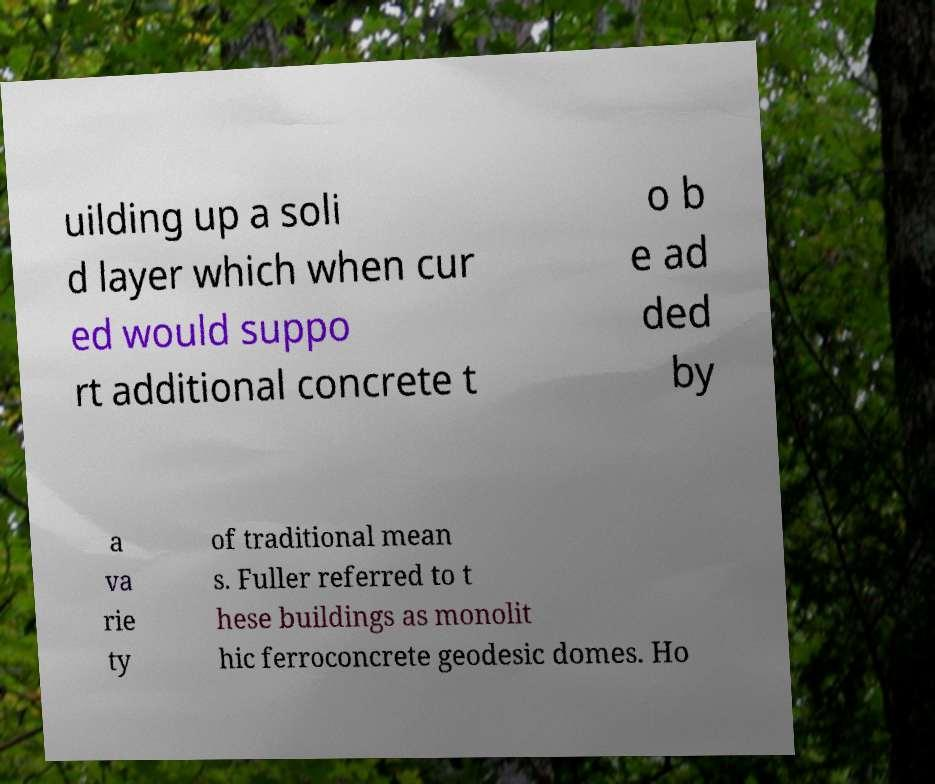For documentation purposes, I need the text within this image transcribed. Could you provide that? uilding up a soli d layer which when cur ed would suppo rt additional concrete t o b e ad ded by a va rie ty of traditional mean s. Fuller referred to t hese buildings as monolit hic ferroconcrete geodesic domes. Ho 